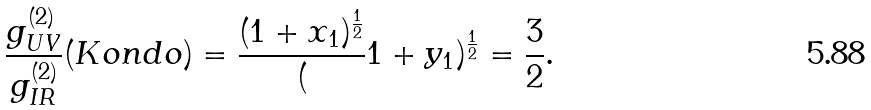Convert formula to latex. <formula><loc_0><loc_0><loc_500><loc_500>\frac { g _ { U V } ^ { ( 2 ) } } { g _ { I R } ^ { ( 2 ) } } ( K o n d o ) = \frac { ( 1 + x _ { 1 } ) ^ { \frac { 1 } { 2 } } } ( 1 + y _ { 1 } ) ^ { \frac { 1 } { 2 } } = \frac { 3 } { 2 } .</formula> 